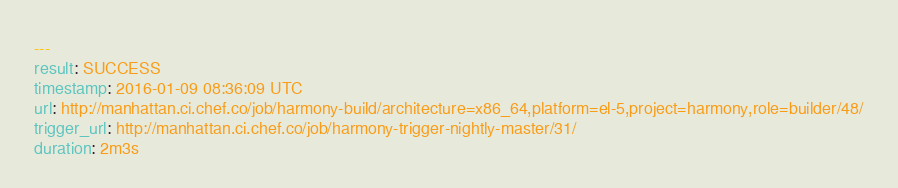Convert code to text. <code><loc_0><loc_0><loc_500><loc_500><_YAML_>---
result: SUCCESS
timestamp: 2016-01-09 08:36:09 UTC
url: http://manhattan.ci.chef.co/job/harmony-build/architecture=x86_64,platform=el-5,project=harmony,role=builder/48/
trigger_url: http://manhattan.ci.chef.co/job/harmony-trigger-nightly-master/31/
duration: 2m3s
</code> 